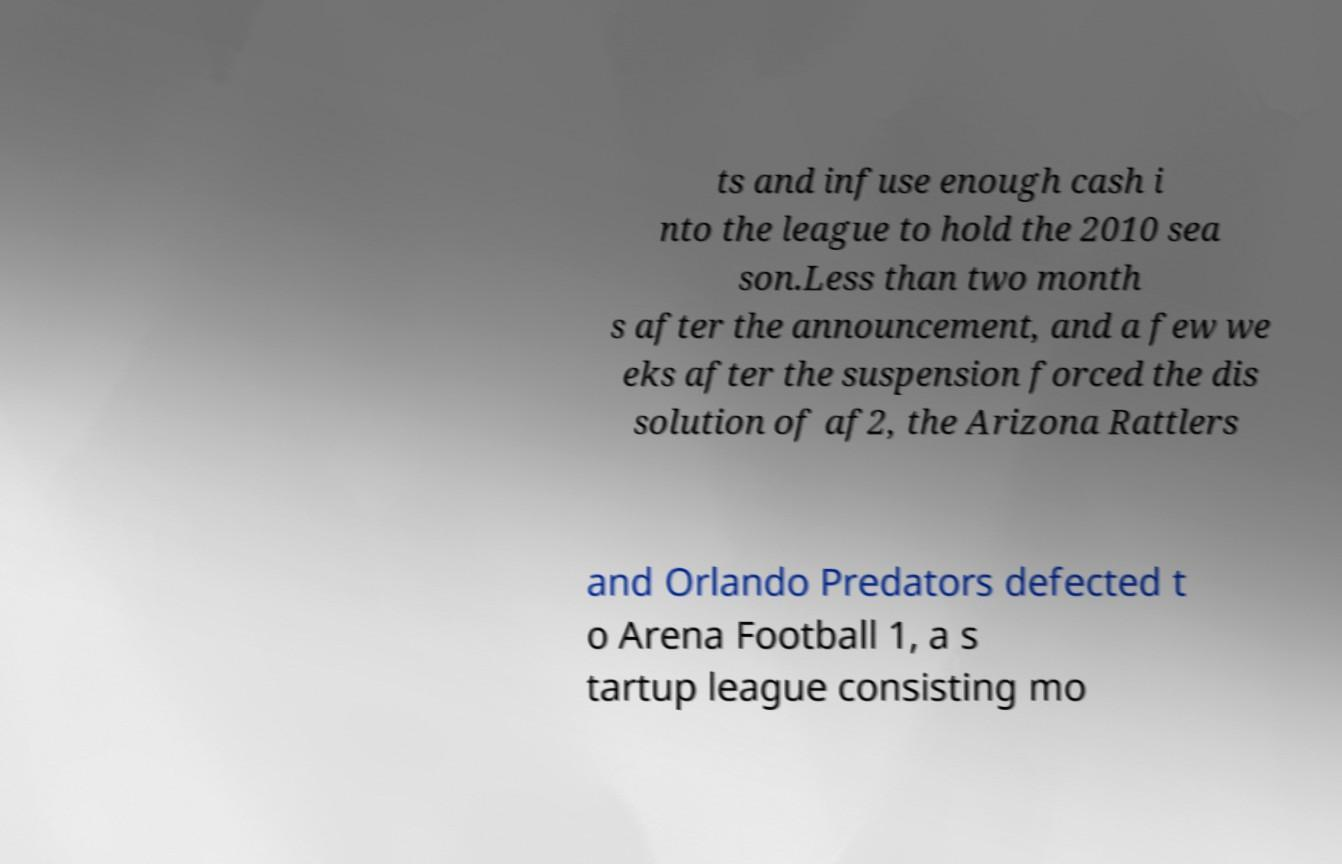There's text embedded in this image that I need extracted. Can you transcribe it verbatim? ts and infuse enough cash i nto the league to hold the 2010 sea son.Less than two month s after the announcement, and a few we eks after the suspension forced the dis solution of af2, the Arizona Rattlers and Orlando Predators defected t o Arena Football 1, a s tartup league consisting mo 